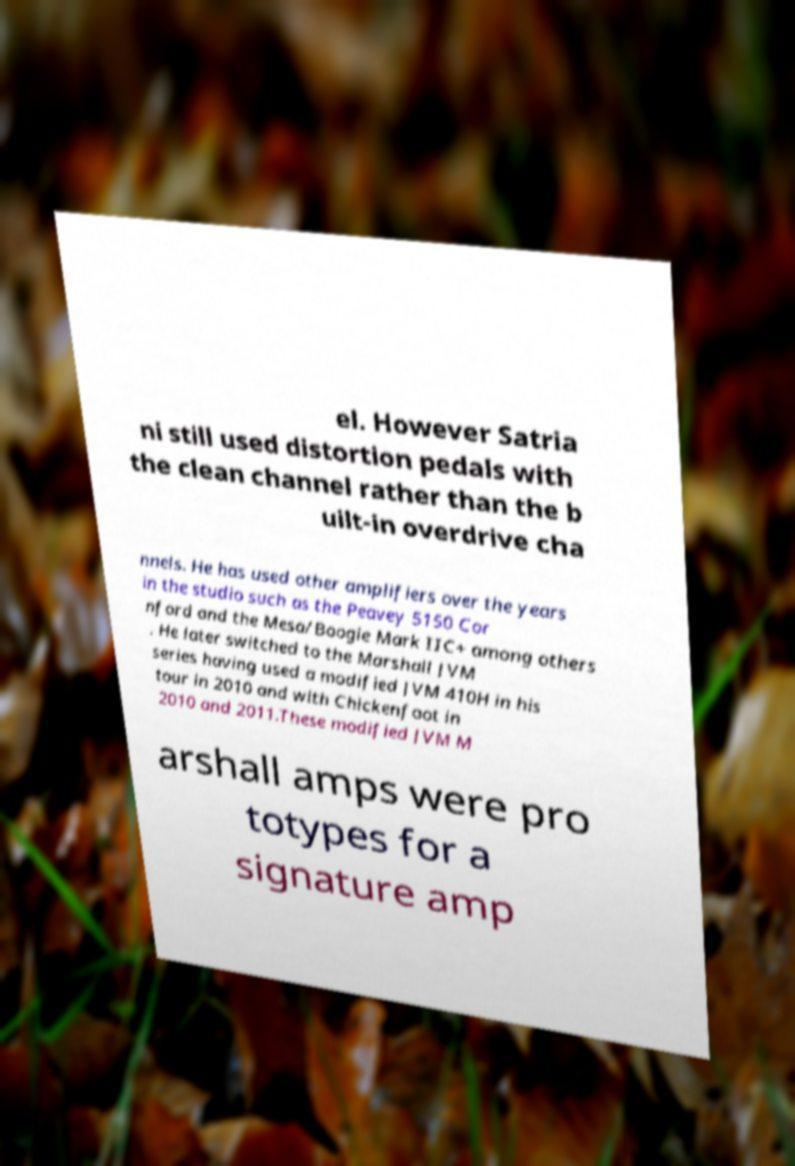I need the written content from this picture converted into text. Can you do that? el. However Satria ni still used distortion pedals with the clean channel rather than the b uilt-in overdrive cha nnels. He has used other amplifiers over the years in the studio such as the Peavey 5150 Cor nford and the Mesa/Boogie Mark IIC+ among others . He later switched to the Marshall JVM series having used a modified JVM 410H in his tour in 2010 and with Chickenfoot in 2010 and 2011.These modified JVM M arshall amps were pro totypes for a signature amp 